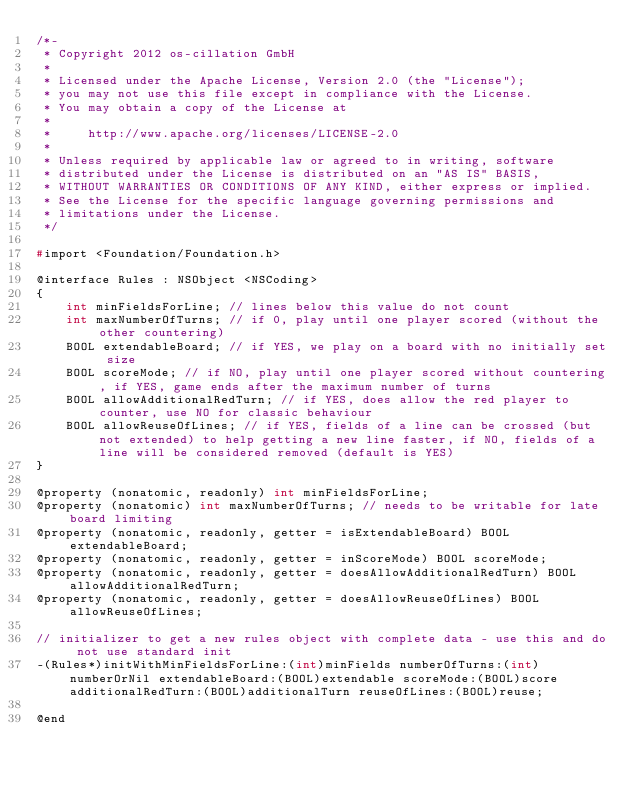Convert code to text. <code><loc_0><loc_0><loc_500><loc_500><_C_>/*-
 * Copyright 2012 os-cillation GmbH
 *
 * Licensed under the Apache License, Version 2.0 (the "License");
 * you may not use this file except in compliance with the License.
 * You may obtain a copy of the License at
 *
 *     http://www.apache.org/licenses/LICENSE-2.0
 *
 * Unless required by applicable law or agreed to in writing, software
 * distributed under the License is distributed on an "AS IS" BASIS,
 * WITHOUT WARRANTIES OR CONDITIONS OF ANY KIND, either express or implied.
 * See the License for the specific language governing permissions and
 * limitations under the License.
 */

#import <Foundation/Foundation.h>

@interface Rules : NSObject <NSCoding>
{
    int minFieldsForLine; // lines below this value do not count
    int maxNumberOfTurns; // if 0, play until one player scored (without the other countering)
    BOOL extendableBoard; // if YES, we play on a board with no initially set size
    BOOL scoreMode; // if NO, play until one player scored without countering, if YES, game ends after the maximum number of turns
    BOOL allowAdditionalRedTurn; // if YES, does allow the red player to counter, use NO for classic behaviour
    BOOL allowReuseOfLines; // if YES, fields of a line can be crossed (but not extended) to help getting a new line faster, if NO, fields of a line will be considered removed (default is YES)
}

@property (nonatomic, readonly) int minFieldsForLine;
@property (nonatomic) int maxNumberOfTurns; // needs to be writable for late board limiting
@property (nonatomic, readonly, getter = isExtendableBoard) BOOL extendableBoard;
@property (nonatomic, readonly, getter = inScoreMode) BOOL scoreMode;
@property (nonatomic, readonly, getter = doesAllowAdditionalRedTurn) BOOL allowAdditionalRedTurn;
@property (nonatomic, readonly, getter = doesAllowReuseOfLines) BOOL allowReuseOfLines;

// initializer to get a new rules object with complete data - use this and do not use standard init
-(Rules*)initWithMinFieldsForLine:(int)minFields numberOfTurns:(int)numberOrNil extendableBoard:(BOOL)extendable scoreMode:(BOOL)score additionalRedTurn:(BOOL)additionalTurn reuseOfLines:(BOOL)reuse;

@end
</code> 